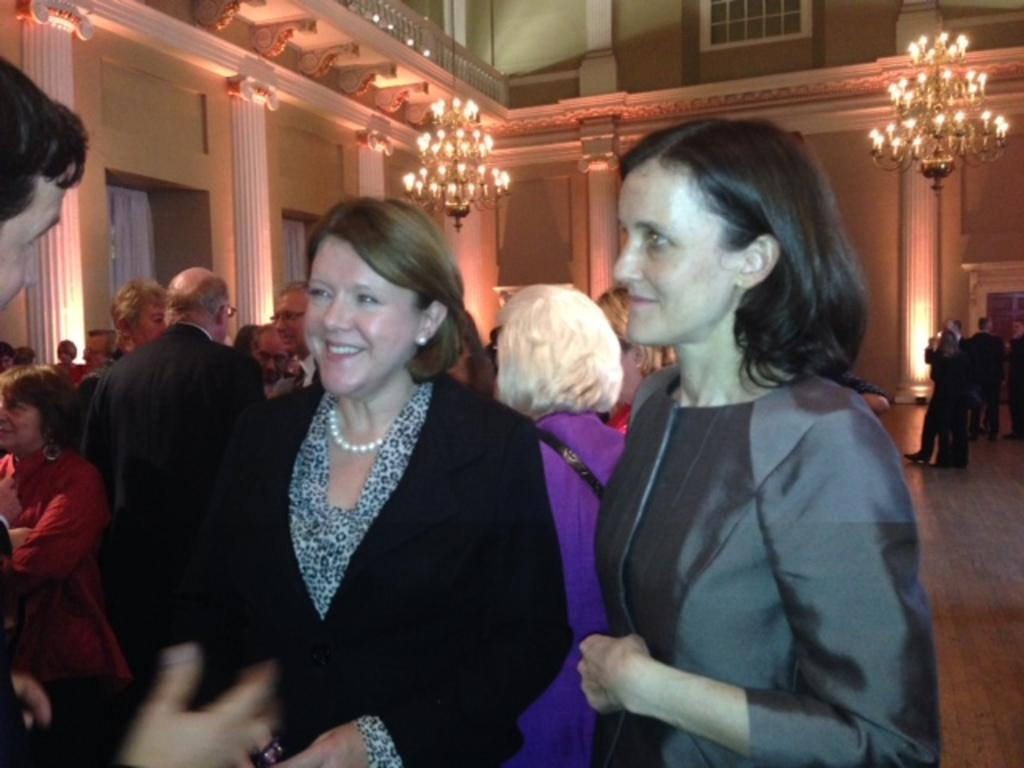How many people are in the group in the image? There is a group of people in the image, but the exact number is not specified. What is one person in the group wearing? One person in the group is wearing a black color blazer. What can be seen in the background of the image? There are two chandeliers, dollar bills, and curtains visible in the background of the image. What type of shirt is the person wearing in the winter season in the image? There is no information about the person's shirt or the season in the image. What attraction is visible in the background of the image? There is no attraction visible in the background of the image; only chandeliers, dollar bills, and curtains are present. 